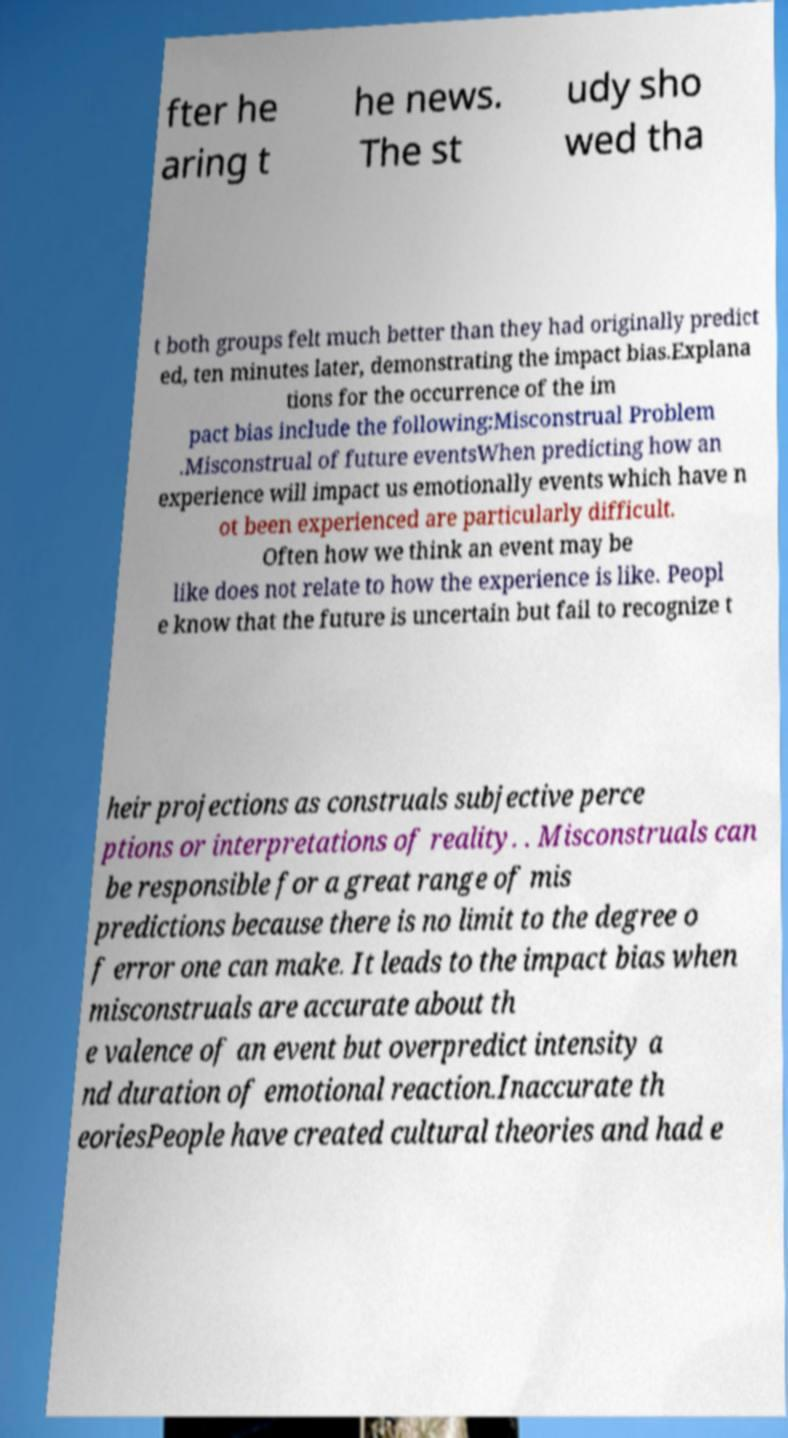Please identify and transcribe the text found in this image. fter he aring t he news. The st udy sho wed tha t both groups felt much better than they had originally predict ed, ten minutes later, demonstrating the impact bias.Explana tions for the occurrence of the im pact bias include the following:Misconstrual Problem .Misconstrual of future eventsWhen predicting how an experience will impact us emotionally events which have n ot been experienced are particularly difficult. Often how we think an event may be like does not relate to how the experience is like. Peopl e know that the future is uncertain but fail to recognize t heir projections as construals subjective perce ptions or interpretations of reality. . Misconstruals can be responsible for a great range of mis predictions because there is no limit to the degree o f error one can make. It leads to the impact bias when misconstruals are accurate about th e valence of an event but overpredict intensity a nd duration of emotional reaction.Inaccurate th eoriesPeople have created cultural theories and had e 